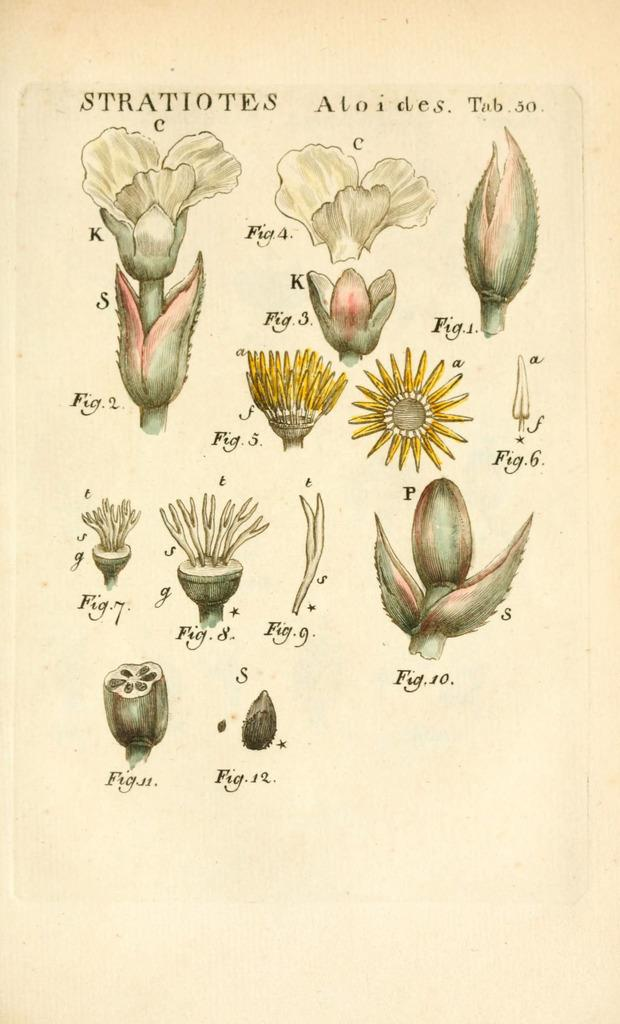What is present in the image related to paper? There is a paper in the image. What is depicted on the paper? The paper contains diagrams of flowers. Are there any words or symbols on the paper? Yes, there is text on the paper. What type of collar is visible on the flowers in the image? There are no collars present in the image, as it features diagrams of flowers on a paper. 